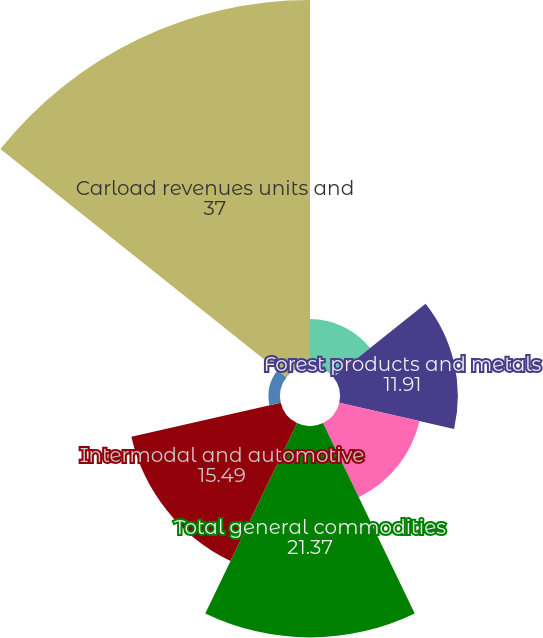Convert chart. <chart><loc_0><loc_0><loc_500><loc_500><pie_chart><fcel>Chemical and petroleum<fcel>Forest products and metals<fcel>Agriculture and minerals<fcel>Total general commodities<fcel>Intermodal and automotive<fcel>Coal<fcel>Carload revenues units and<nl><fcel>4.74%<fcel>11.91%<fcel>8.32%<fcel>21.37%<fcel>15.49%<fcel>1.16%<fcel>37.0%<nl></chart> 